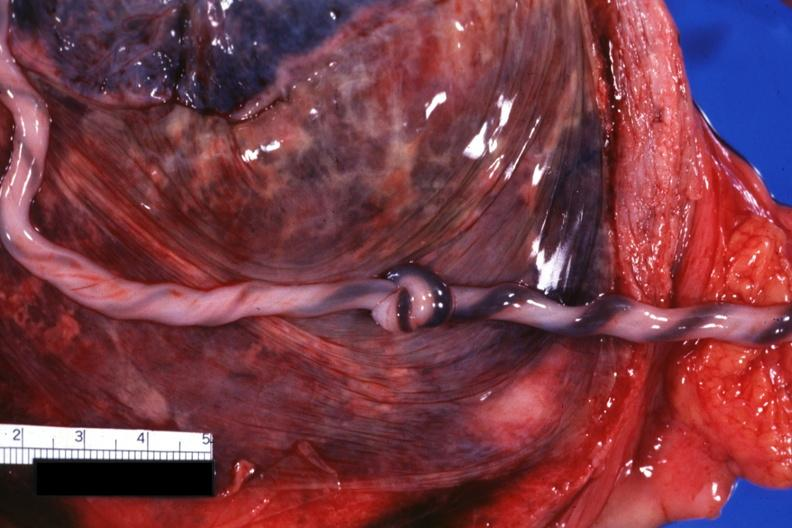what does this image show?
Answer the question using a single word or phrase. Well shown knot 